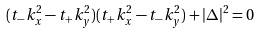Convert formula to latex. <formula><loc_0><loc_0><loc_500><loc_500>( t _ { - } k _ { x } ^ { 2 } - t _ { + } k _ { y } ^ { 2 } ) ( t _ { + } k _ { x } ^ { 2 } - t _ { - } k _ { y } ^ { 2 } ) + | \Delta | ^ { 2 } = 0</formula> 